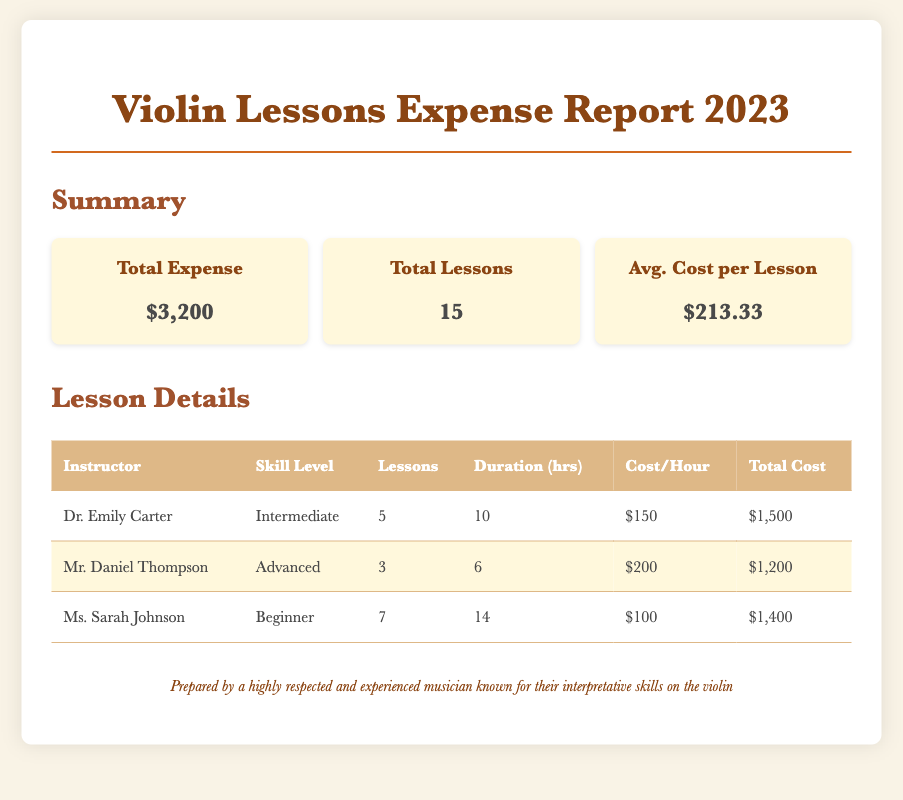What is the total expense? The total expense is a key figure summarizing all costs associated with the lessons, which is $3,200.
Answer: $3,200 How many total lessons were attended? The report provides a summary count of all lessons taken, which amounts to 15.
Answer: 15 Who is the instructor with the highest total cost? By comparing the total costs across all instructors, the one with the highest cost is Dr. Emily Carter with $1,500.
Answer: Dr. Emily Carter What is the average cost per lesson? The average cost is calculated by dividing the total expense by the total lessons, which equals $213.33.
Answer: $213.33 How many hours of lessons did Ms. Sarah Johnson conduct? The document details that Ms. Sarah Johnson conducted a total of 14 hours of lessons.
Answer: 14 Which skill level has the most lessons? By analyzing the lesson distribution, it shows that Beginner has the most lessons at 7.
Answer: Beginner What is the cost per hour for Mr. Daniel Thompson? The report specifies Mr. Daniel Thompson's cost per hour, which is $200.
Answer: $200 What is the total cost for all lessons with Ms. Sarah Johnson? The total cost for Ms. Sarah Johnson’s lessons is given in the details, amounting to $1,400.
Answer: $1,400 How many hours of lessons did Dr. Emily Carter conduct? The document indicates that Dr. Emily Carter conducted a total of 10 hours of lessons.
Answer: 10 